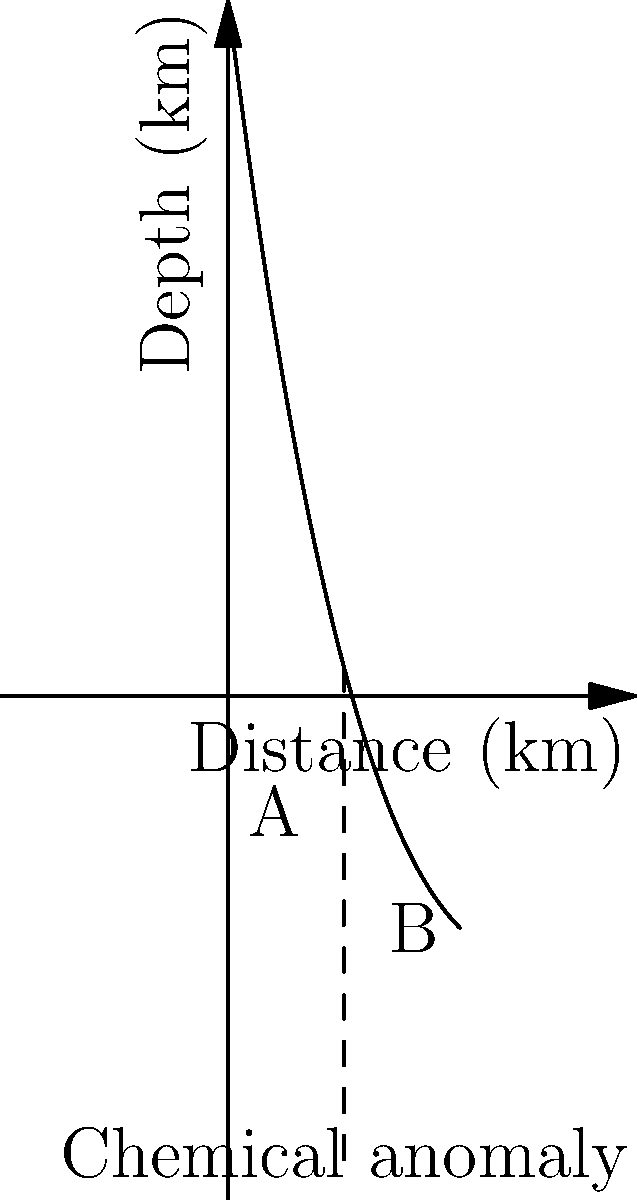In a newly discovered deep-sea trench, you've detected a unique chemical composition at point A. As you move towards point B, the chemical concentration gradually changes. Given that the topography follows the function $f(x) = -0.01x^3 + 0.5x^2 - 8x + 30$, where $x$ is the distance in kilometers and $f(x)$ is the depth in kilometers, what is the rate of change of depth with respect to distance at the point of the chemical anomaly (x = 5 km)? To solve this problem, we need to follow these steps:

1) The rate of change of depth with respect to distance is given by the derivative of the function $f(x)$.

2) Let's find the derivative of $f(x) = -0.01x^3 + 0.5x^2 - 8x + 30$:
   
   $f'(x) = -0.03x^2 + x - 8$

3) We need to evaluate this derivative at x = 5 km (the point of the chemical anomaly):

   $f'(5) = -0.03(5)^2 + 5 - 8$
   
   $= -0.03(25) + 5 - 8$
   
   $= -0.75 + 5 - 8$
   
   $= -3.75$

4) The negative value indicates that the depth is increasing as we move along the x-axis.

5) Therefore, at the point of the chemical anomaly, the rate of change of depth with respect to distance is -3.75 km/km.
Answer: -3.75 km/km 